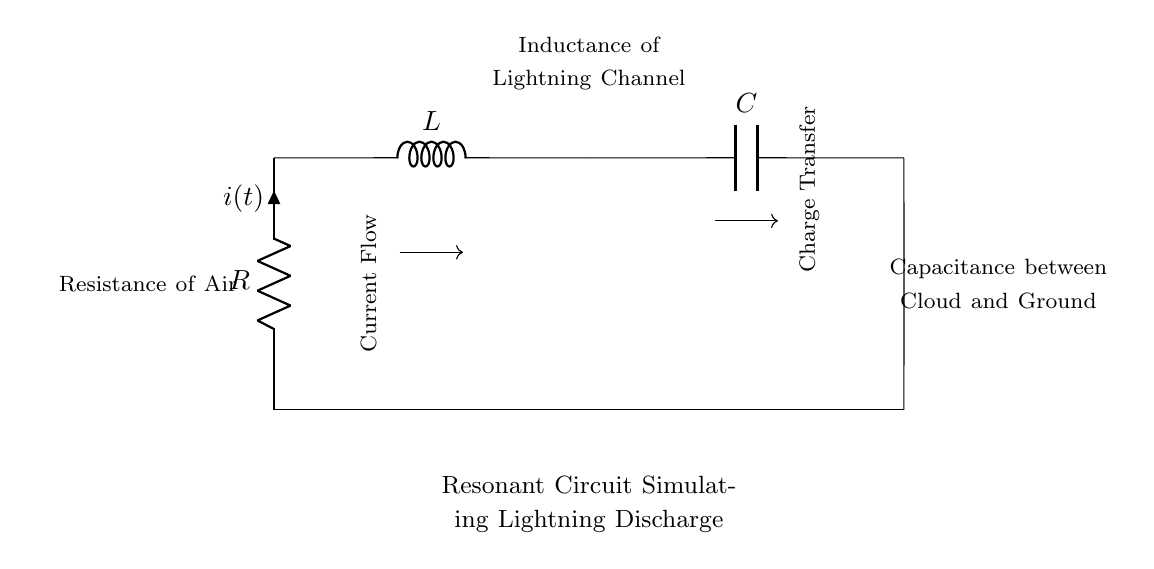What are the components of the circuit? The circuit contains a resistor, an inductor, and a capacitor, as indicated by the symbols R, L, and C in the diagram.
Answer: resistor, inductor, capacitor What does R represent in this circuit? R represents the resistance provided by the air, which opposes the flow of electric current in the circuit.
Answer: Resistance of Air What does L represent in this circuit? L represents the inductance of the lightning channel, which stores energy in the magnetic field when current flows through it.
Answer: Inductance of Lightning Channel What charge transfer is occurring in this circuit? The charge transfer occurs between the capacitor and the ground, which is the capacitance between the cloud and ground.
Answer: Charge Transfer How does the circuit respond to lightning discharge? The circuit resonates due to the interaction between resistance, inductance, and capacitance, simulating the behavior of lightning discharge as energy oscillates between these components.
Answer: Resonance What is the effect of adding more capacitance in this circuit? Increasing capacitance would lower the resonant frequency of the circuit, which means it would take longer for the circuit to discharge, potentially simulating a prolonged lightning event.
Answer: Lowers resonant frequency What is the purpose of including inductance in this circuit? Including inductance provides the ability to store energy and facilitates oscillations in the circuit, which is crucial for simulating the rapid discharge of energy seen in lightning.
Answer: Energy storage and oscillation 